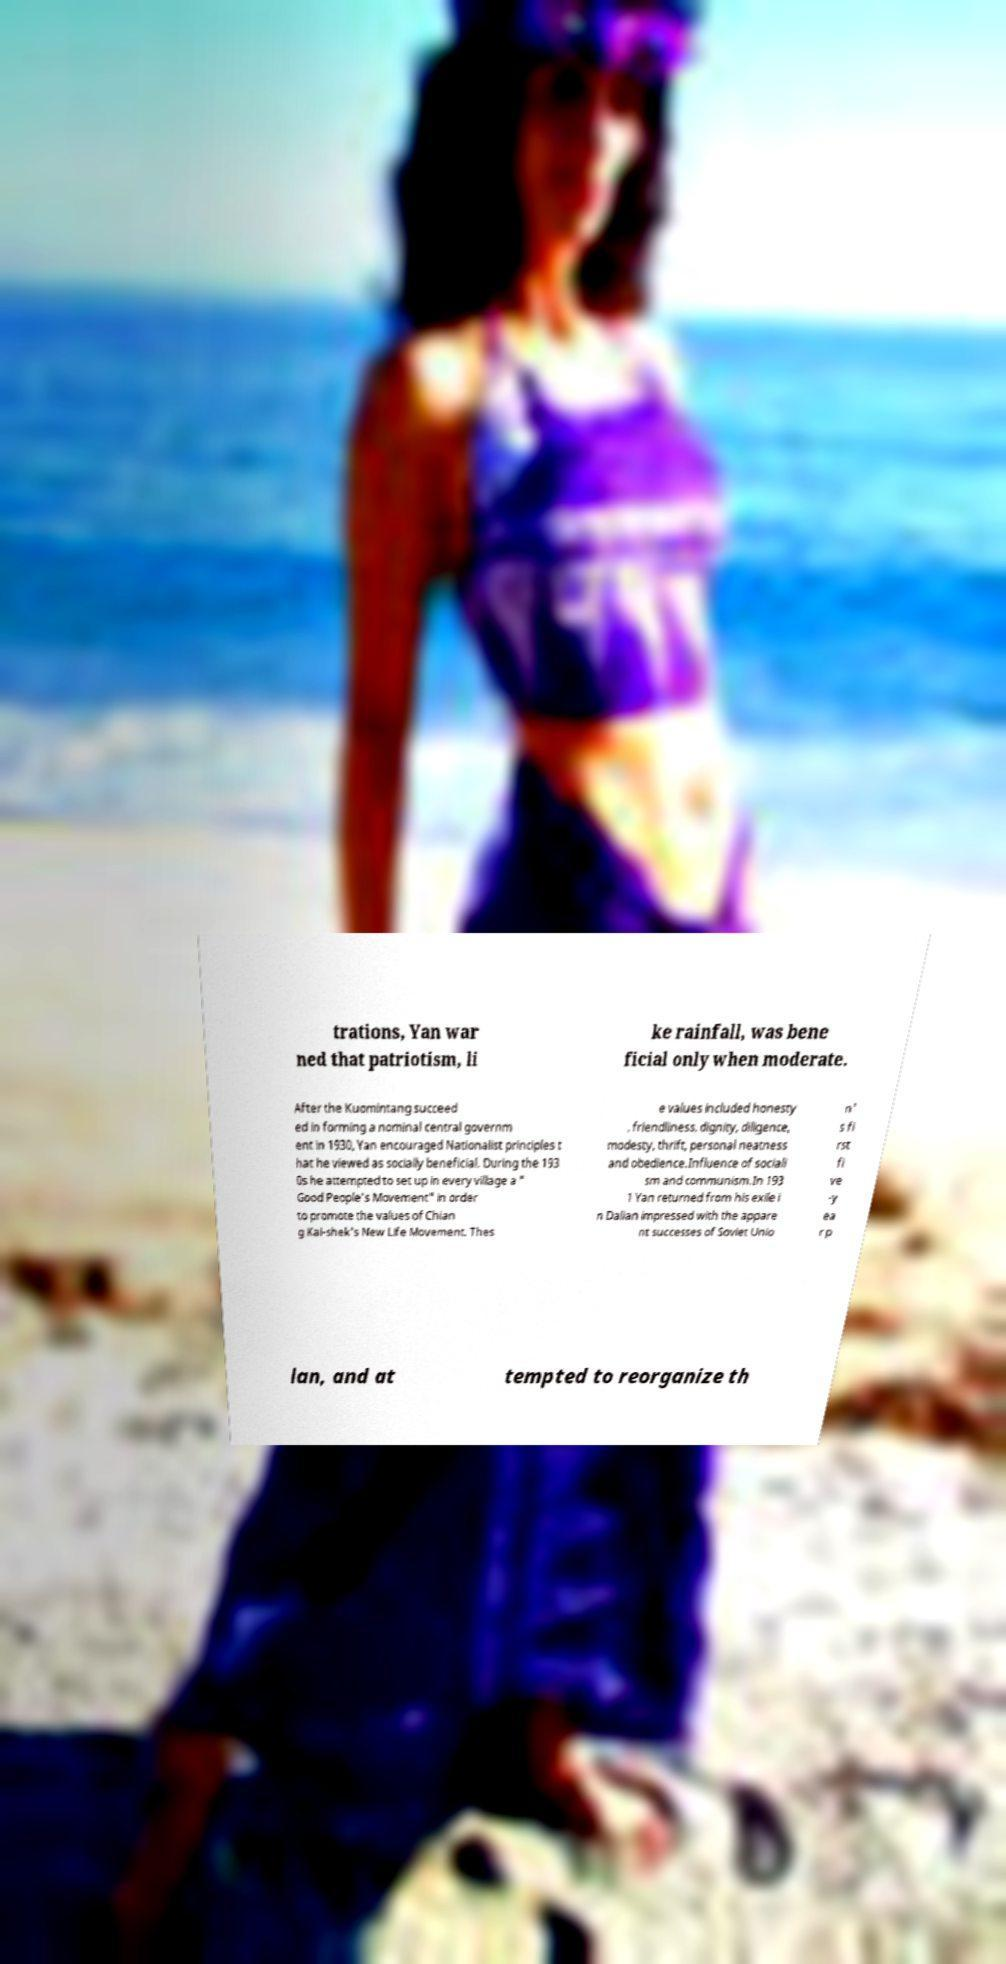Can you accurately transcribe the text from the provided image for me? trations, Yan war ned that patriotism, li ke rainfall, was bene ficial only when moderate. After the Kuomintang succeed ed in forming a nominal central governm ent in 1930, Yan encouraged Nationalist principles t hat he viewed as socially beneficial. During the 193 0s he attempted to set up in every village a " Good People's Movement" in order to promote the values of Chian g Kai-shek's New Life Movement. Thes e values included honesty , friendliness, dignity, diligence, modesty, thrift, personal neatness and obedience.Influence of sociali sm and communism.In 193 1 Yan returned from his exile i n Dalian impressed with the appare nt successes of Soviet Unio n' s fi rst fi ve -y ea r p lan, and at tempted to reorganize th 